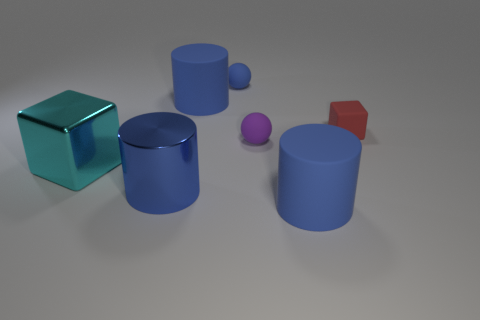Are there any other things that have the same size as the purple object?
Ensure brevity in your answer.  Yes. There is a cyan thing; is its size the same as the blue cylinder behind the small red block?
Ensure brevity in your answer.  Yes. How many large matte things are there?
Your answer should be compact. 2. There is a blue cylinder behind the large cyan object; is it the same size as the block on the right side of the big blue shiny thing?
Provide a succinct answer. No. What is the color of the tiny rubber object that is the same shape as the big cyan object?
Provide a succinct answer. Red. Is the purple matte thing the same shape as the small blue object?
Offer a very short reply. Yes. There is a cyan object that is the same shape as the tiny red object; what size is it?
Keep it short and to the point. Large. What number of blue things are made of the same material as the cyan thing?
Give a very brief answer. 1. What number of objects are tiny blue spheres or tiny shiny blocks?
Your response must be concise. 1. Are there any small objects that are to the right of the tiny blue sphere behind the big cyan cube?
Your answer should be very brief. Yes. 